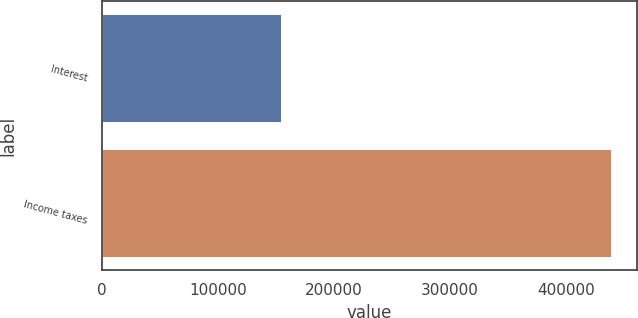Convert chart to OTSL. <chart><loc_0><loc_0><loc_500><loc_500><bar_chart><fcel>Interest<fcel>Income taxes<nl><fcel>154310<fcel>438840<nl></chart> 